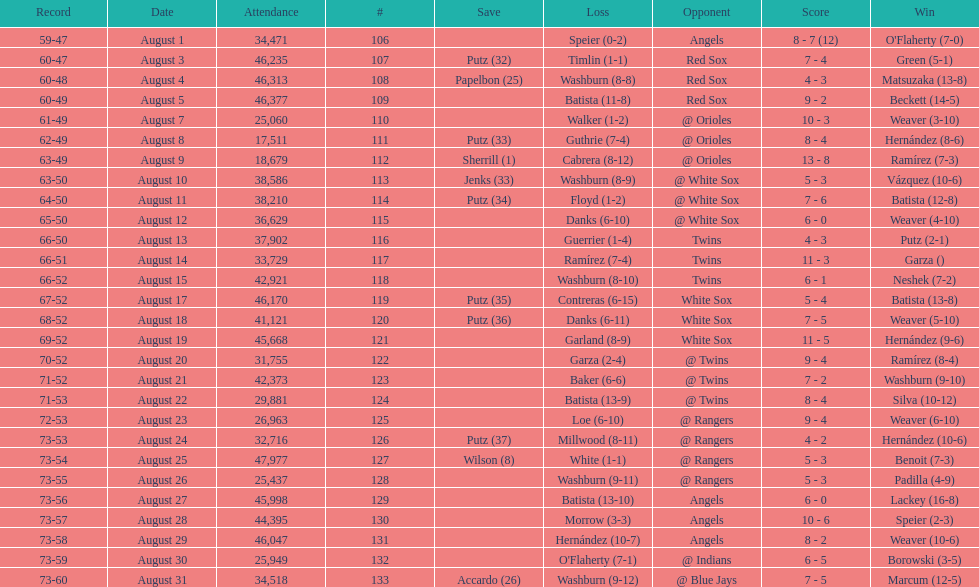Games above 30,000 in attendance 21. 